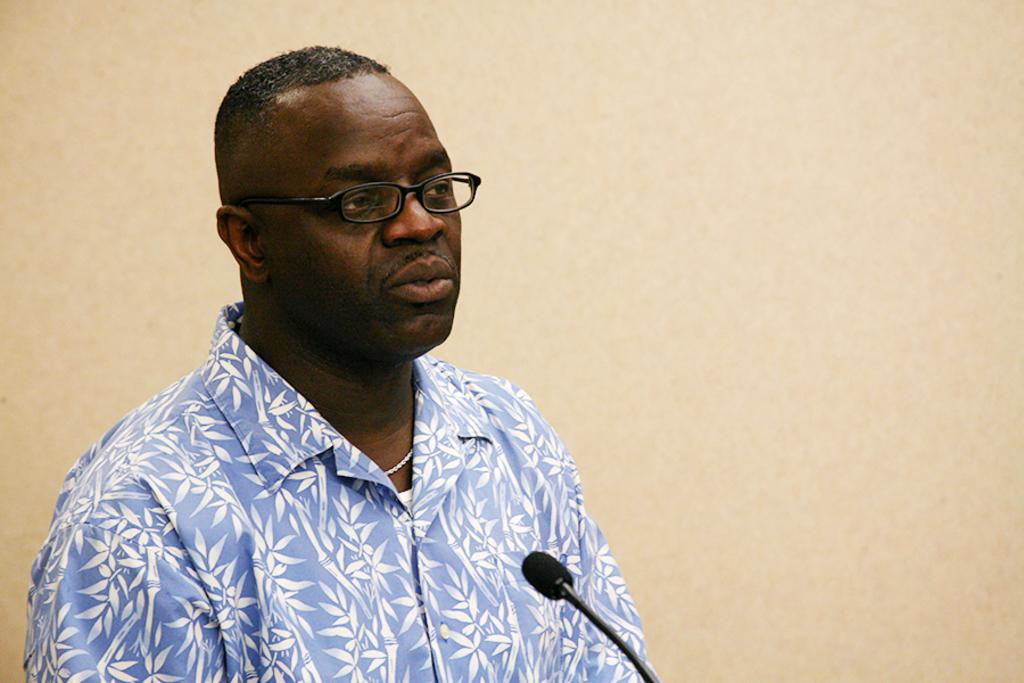What is the person in the image doing? The person is talking into a mic. Can you describe the setting in which the person is located? There is a wall visible in the image, which suggests an indoor setting. How many fingers does the person have on their left hand in the image? The number of fingers on the person's left hand cannot be determined from the image, as it is not visible. --- Facts: 1. There is a person in the image. 2. The person is holding a book. 3. There is a table in the image. Absurd Topics: bicycle, ocean, parrot Conversation: What is the person in the image holding? The person is holding a book. Can you describe the setting in which the person is located? There is a table in the image, which suggests a possible indoor setting. Reasoning: Let's think step by step in order to produce the conversation. We start by identifying the main subject in the image, which is the person holding a book. Then, we expand the conversation to include the setting in which the person is located, which is indicated by the presence of a table. Each question is designed to elicit a specific detail about the image that is known from the provided facts. Absurd Question/Answer: Can you see a bicycle in the image? No, there is no bicycle present in the image. What type of parrot is sitting on the table in the image? There is no parrot present in the image. --- Facts: 1. There is a person in the image. 2. The person is wearing a hat. 3. There is a tree in the image. Absurd Topics: car, volcano, spaceship Conversation: What is the person in the image wearing on their head? The person is wearing a hat. Can you describe the setting in which the person is located? There is a tree in the image, which suggests a possible outdoor setting. Reasoning: Let's think step by step in order to produce the conversation. We start by identifying the main subject in the image, which is the person wearing a hat. Then, we expand the conversation to include the setting in which the person is located, which is indicated by the presence of a tree. Each question is designed to elicit a specific detail about the image that is known from the provided facts. Absurd Question/Answer: Is there a car parked next to the tree in the image? No, there is no car present in the image. Can you see a volcano in the image? No, there is no volcano present in the image. --- Facts: 1. There is a person in the image. 2. The person is holding a camera. 3. There is a building in the image. Absurd Topics: elephant, snow, beach 